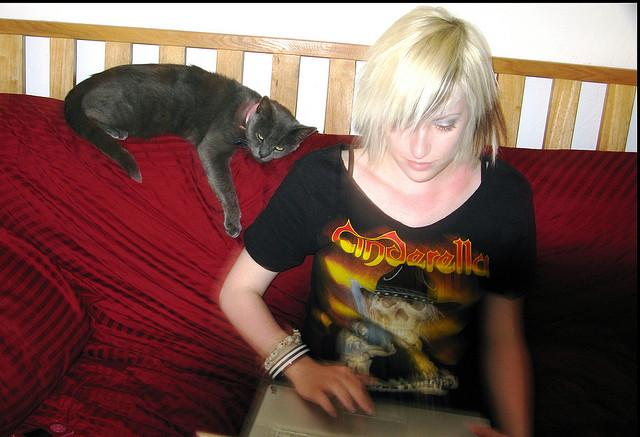What type of furniture is the girl sitting on? Please explain your reasoning. futon. The girl is sitting on some sort of couch. 